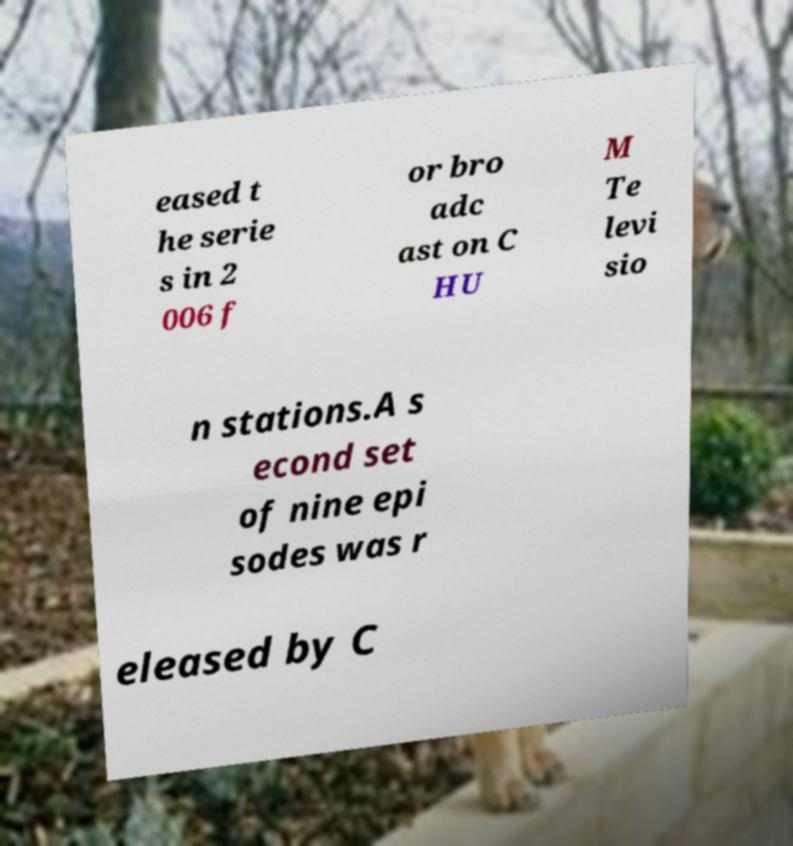Can you read and provide the text displayed in the image?This photo seems to have some interesting text. Can you extract and type it out for me? eased t he serie s in 2 006 f or bro adc ast on C HU M Te levi sio n stations.A s econd set of nine epi sodes was r eleased by C 